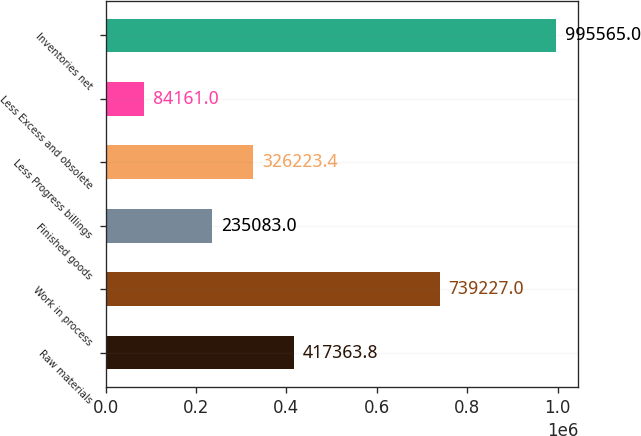Convert chart to OTSL. <chart><loc_0><loc_0><loc_500><loc_500><bar_chart><fcel>Raw materials<fcel>Work in process<fcel>Finished goods<fcel>Less Progress billings<fcel>Less Excess and obsolete<fcel>Inventories net<nl><fcel>417364<fcel>739227<fcel>235083<fcel>326223<fcel>84161<fcel>995565<nl></chart> 